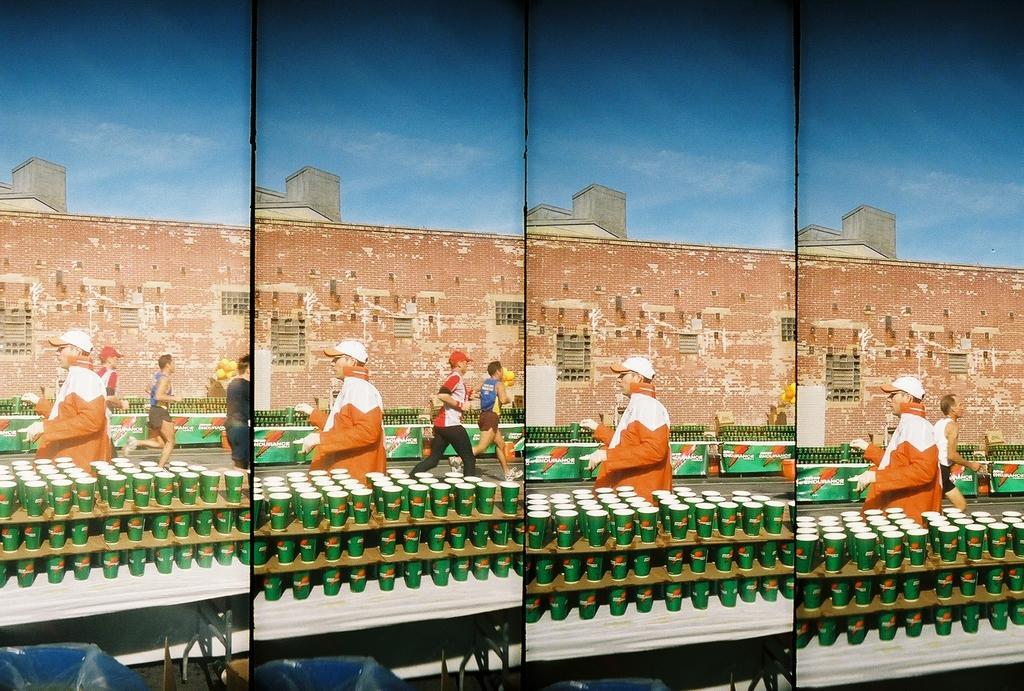Please provide a concise description of this image. This is an edited image with the collage of images. In the foreground we can see the tables on the top of which there are some green color objects seems to be the glasses. In the center we can see the group of persons running on the ground. In the background we can see the sky, buildings, windows of the buildings and many other objects. In the foreground we can see some blue color objects. 